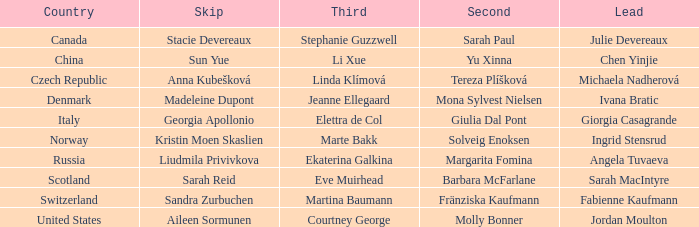In which skip does angela tuvaeva play the leading part? Liudmila Privivkova. 